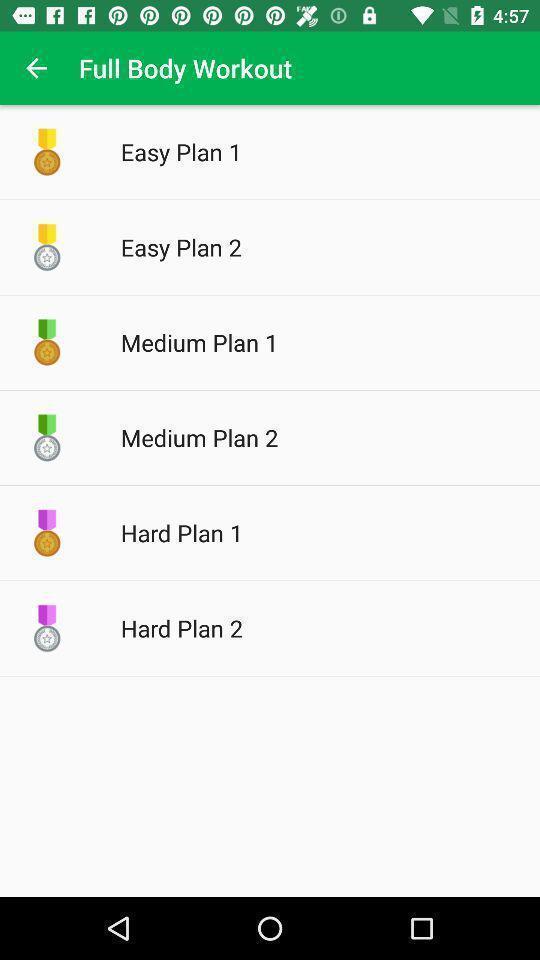Give me a summary of this screen capture. Screen displaying multiple workout plans in a fitness application. 